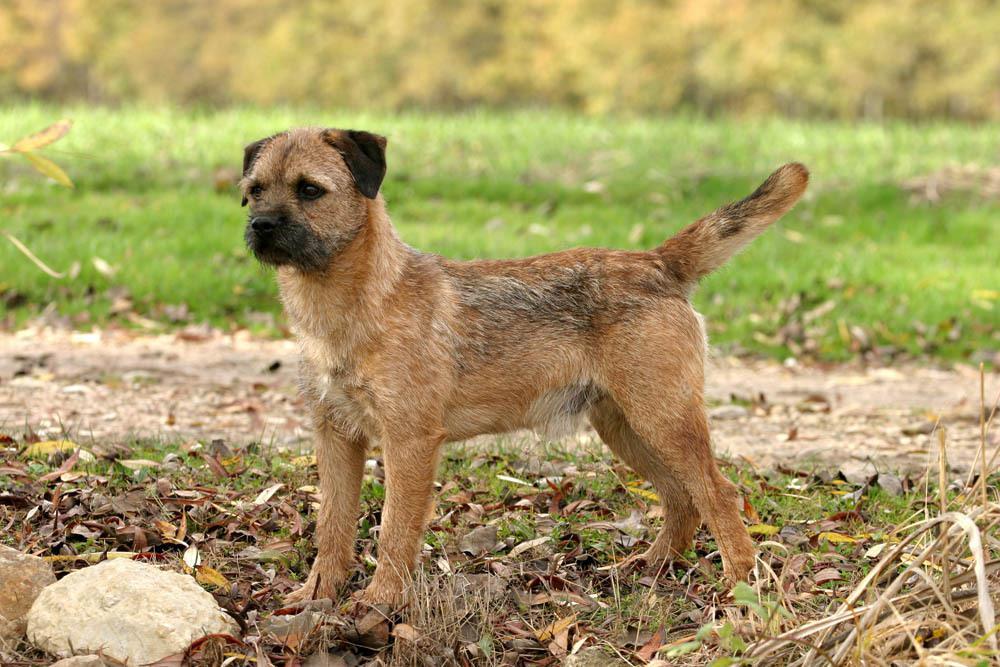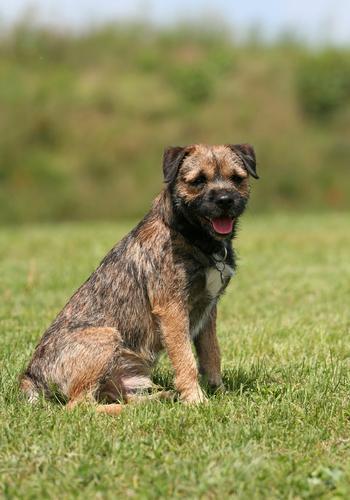The first image is the image on the left, the second image is the image on the right. Examine the images to the left and right. Is the description "Each image contains only one dog and one is sitting in one image and standing in the other image." accurate? Answer yes or no. Yes. The first image is the image on the left, the second image is the image on the right. Assess this claim about the two images: "There is a dog in the right image, sitting down.". Correct or not? Answer yes or no. Yes. 